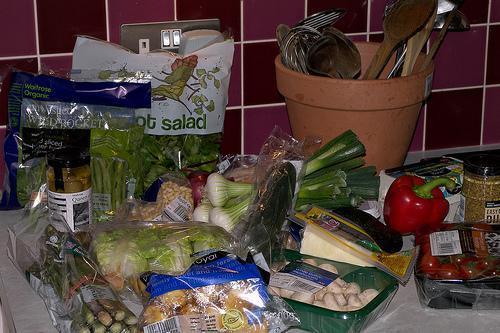How many peppers are there?
Give a very brief answer. 1. 